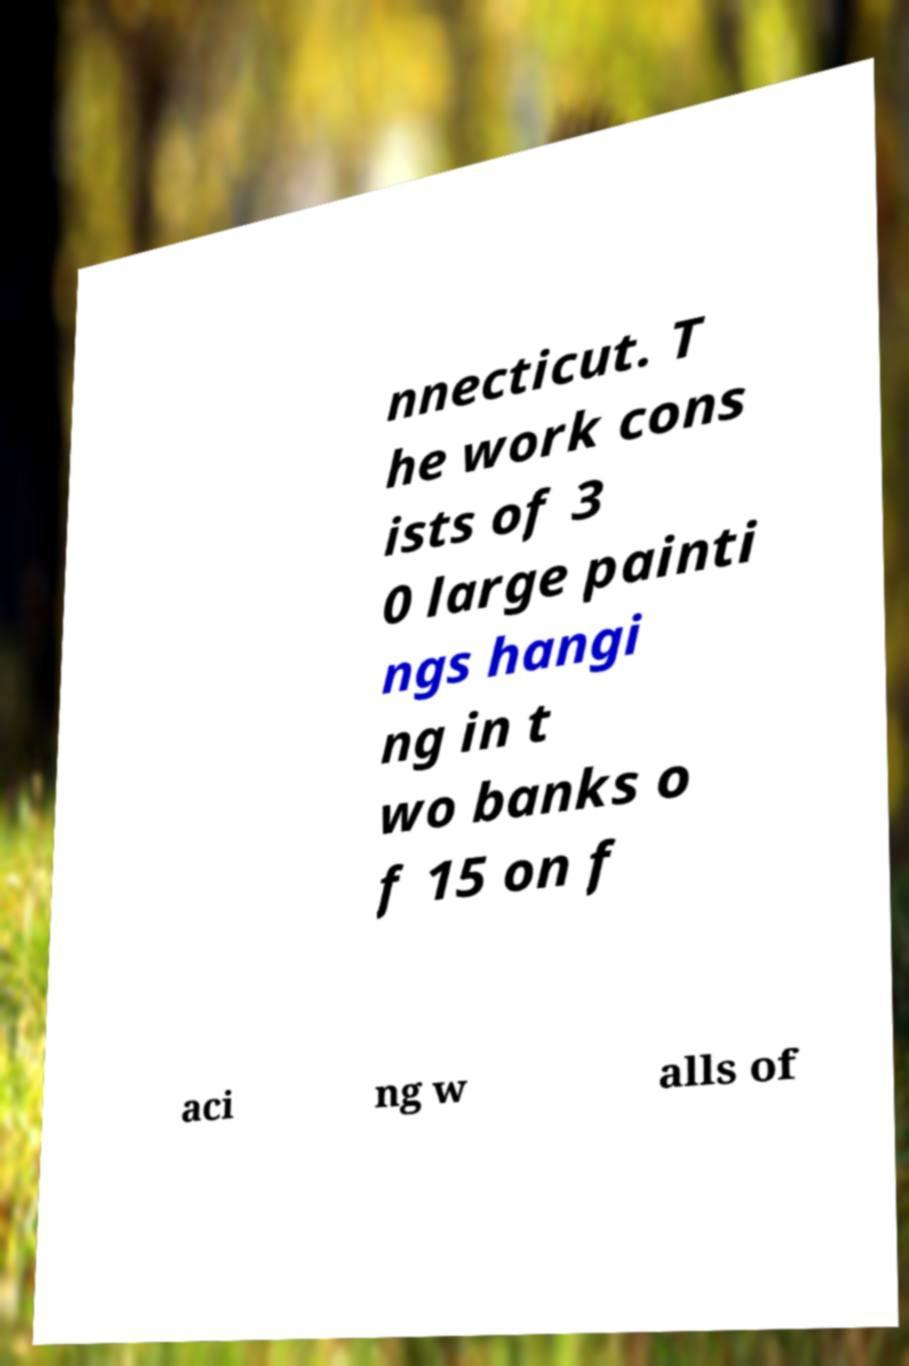Can you read and provide the text displayed in the image?This photo seems to have some interesting text. Can you extract and type it out for me? nnecticut. T he work cons ists of 3 0 large painti ngs hangi ng in t wo banks o f 15 on f aci ng w alls of 